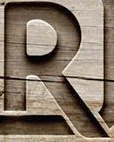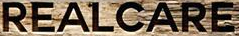What words are shown in these images in order, separated by a semicolon? R; REALCARE 